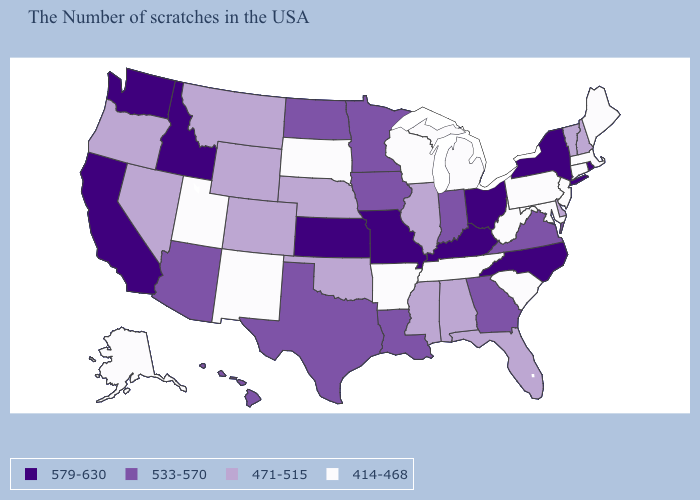Name the states that have a value in the range 533-570?
Keep it brief. Virginia, Georgia, Indiana, Louisiana, Minnesota, Iowa, Texas, North Dakota, Arizona, Hawaii. Which states have the lowest value in the South?
Be succinct. Maryland, South Carolina, West Virginia, Tennessee, Arkansas. What is the value of New York?
Be succinct. 579-630. How many symbols are there in the legend?
Be succinct. 4. What is the value of California?
Keep it brief. 579-630. What is the value of Maine?
Keep it brief. 414-468. Among the states that border Florida , does Georgia have the highest value?
Short answer required. Yes. What is the value of Rhode Island?
Write a very short answer. 579-630. What is the value of Nevada?
Keep it brief. 471-515. Does Alabama have the same value as Nevada?
Answer briefly. Yes. Does Vermont have the lowest value in the Northeast?
Quick response, please. No. Name the states that have a value in the range 414-468?
Be succinct. Maine, Massachusetts, Connecticut, New Jersey, Maryland, Pennsylvania, South Carolina, West Virginia, Michigan, Tennessee, Wisconsin, Arkansas, South Dakota, New Mexico, Utah, Alaska. Among the states that border Alabama , which have the lowest value?
Short answer required. Tennessee. Does South Dakota have the lowest value in the USA?
Quick response, please. Yes. What is the value of Iowa?
Concise answer only. 533-570. 